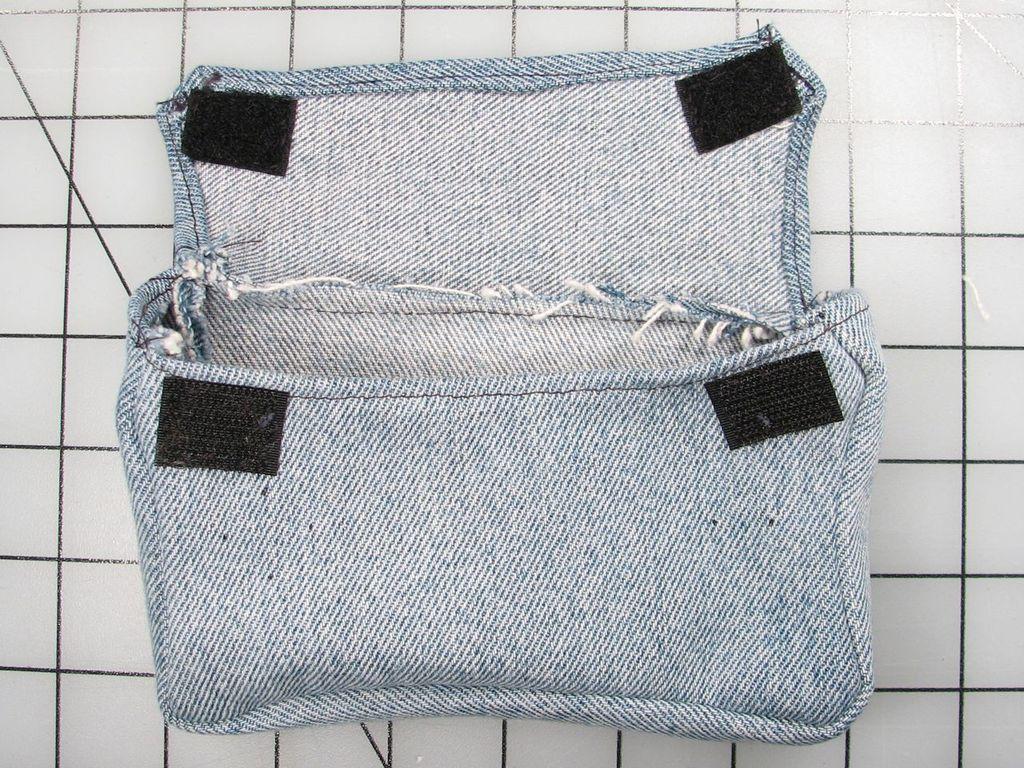In one or two sentences, can you explain what this image depicts? In this image we can see a hand purse, the background is white. 